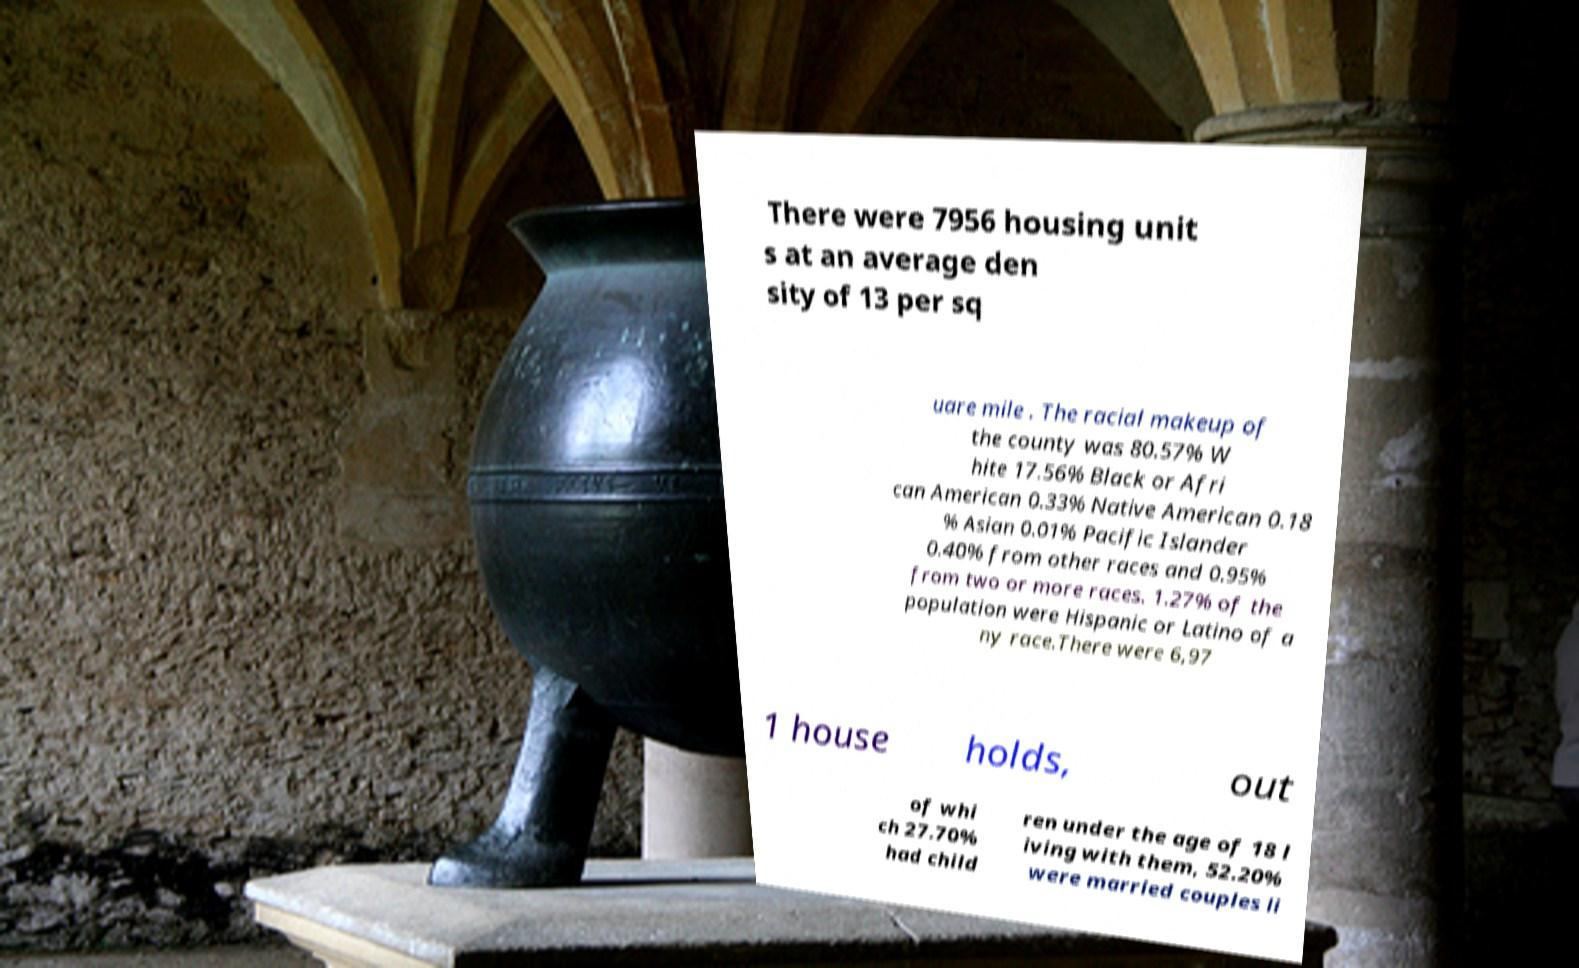Can you accurately transcribe the text from the provided image for me? There were 7956 housing unit s at an average den sity of 13 per sq uare mile . The racial makeup of the county was 80.57% W hite 17.56% Black or Afri can American 0.33% Native American 0.18 % Asian 0.01% Pacific Islander 0.40% from other races and 0.95% from two or more races. 1.27% of the population were Hispanic or Latino of a ny race.There were 6,97 1 house holds, out of whi ch 27.70% had child ren under the age of 18 l iving with them, 52.20% were married couples li 